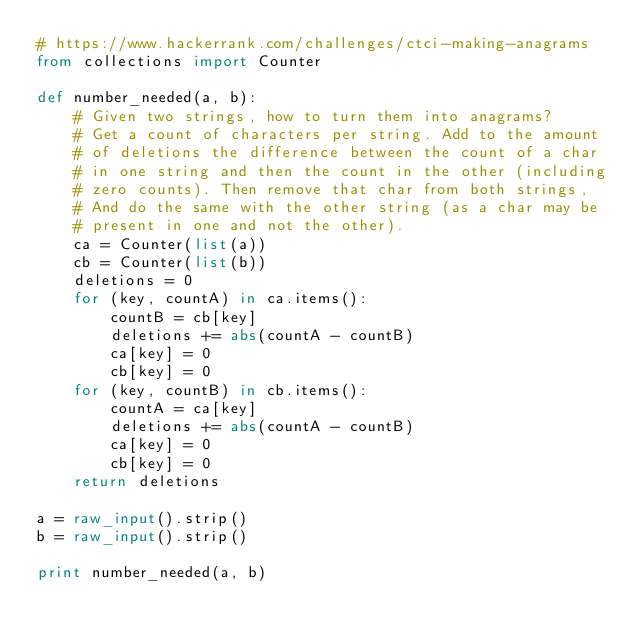<code> <loc_0><loc_0><loc_500><loc_500><_Python_># https://www.hackerrank.com/challenges/ctci-making-anagrams
from collections import Counter

def number_needed(a, b):
    # Given two strings, how to turn them into anagrams?
    # Get a count of characters per string. Add to the amount
    # of deletions the difference between the count of a char
    # in one string and then the count in the other (including
    # zero counts). Then remove that char from both strings,
    # And do the same with the other string (as a char may be
    # present in one and not the other).
    ca = Counter(list(a))
    cb = Counter(list(b))
    deletions = 0
    for (key, countA) in ca.items():
        countB = cb[key]
        deletions += abs(countA - countB)
        ca[key] = 0
        cb[key] = 0
    for (key, countB) in cb.items():
        countA = ca[key]
        deletions += abs(countA - countB)
        ca[key] = 0
        cb[key] = 0
    return deletions
            
a = raw_input().strip()
b = raw_input().strip()

print number_needed(a, b)
</code> 